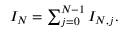Convert formula to latex. <formula><loc_0><loc_0><loc_500><loc_500>\begin{array} { r } { I _ { N } = \sum _ { j = 0 } ^ { N - 1 } I _ { N , j } . } \end{array}</formula> 